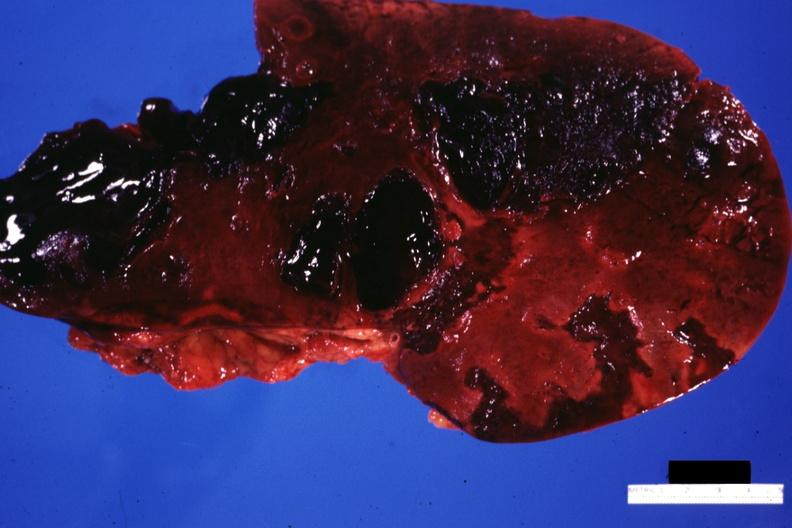what does this image show?
Answer the question using a single word or phrase. Frontal cut surface massive lacerations 